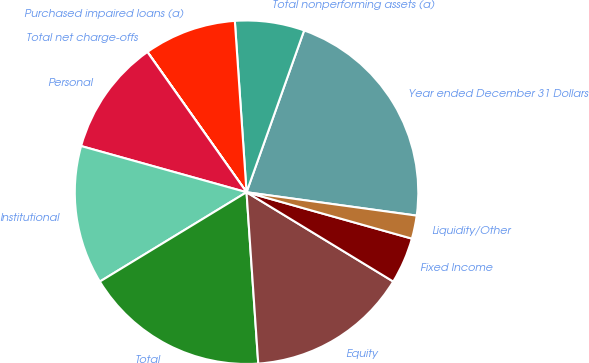<chart> <loc_0><loc_0><loc_500><loc_500><pie_chart><fcel>Year ended December 31 Dollars<fcel>Total nonperforming assets (a)<fcel>Purchased impaired loans (a)<fcel>Total net charge-offs<fcel>Personal<fcel>Institutional<fcel>Total<fcel>Equity<fcel>Fixed Income<fcel>Liquidity/Other<nl><fcel>21.73%<fcel>6.53%<fcel>8.7%<fcel>0.01%<fcel>10.87%<fcel>13.04%<fcel>17.38%<fcel>15.21%<fcel>4.35%<fcel>2.18%<nl></chart> 